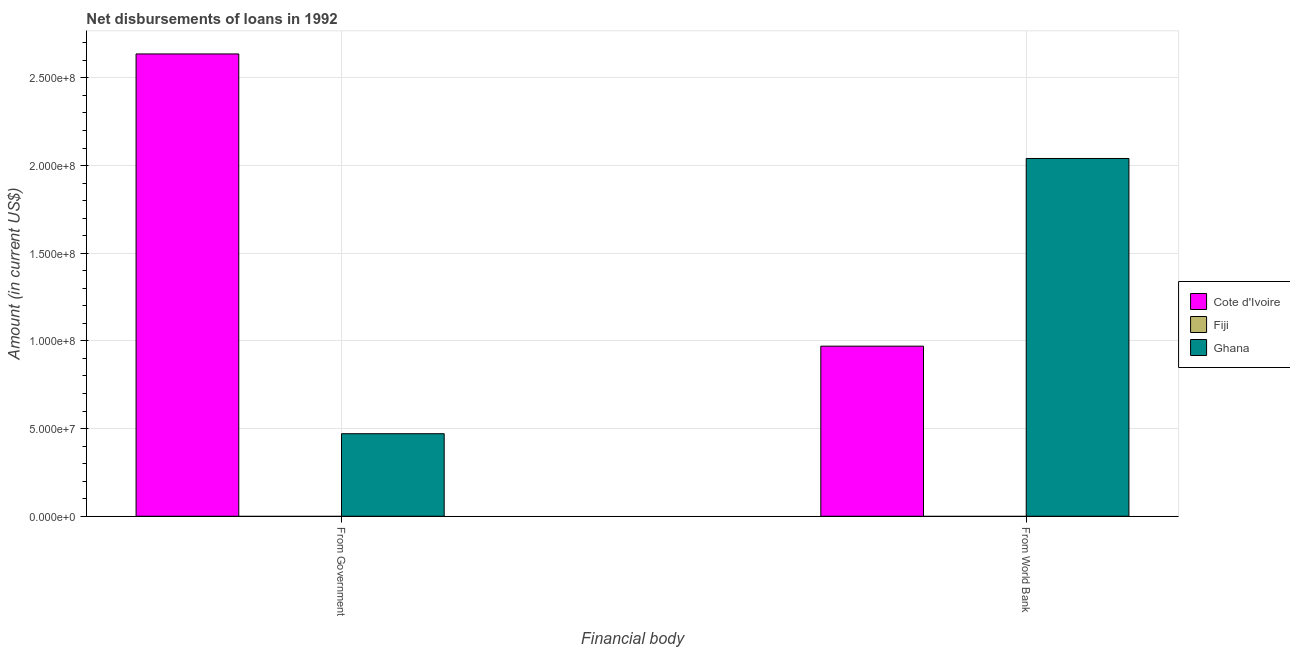How many different coloured bars are there?
Give a very brief answer. 2. Are the number of bars per tick equal to the number of legend labels?
Offer a terse response. No. How many bars are there on the 2nd tick from the left?
Give a very brief answer. 2. How many bars are there on the 2nd tick from the right?
Make the answer very short. 2. What is the label of the 2nd group of bars from the left?
Offer a very short reply. From World Bank. What is the net disbursements of loan from government in Fiji?
Keep it short and to the point. 0. Across all countries, what is the maximum net disbursements of loan from government?
Provide a succinct answer. 2.64e+08. Across all countries, what is the minimum net disbursements of loan from government?
Give a very brief answer. 0. In which country was the net disbursements of loan from world bank maximum?
Give a very brief answer. Ghana. What is the total net disbursements of loan from world bank in the graph?
Your answer should be very brief. 3.01e+08. What is the difference between the net disbursements of loan from government in Ghana and that in Cote d'Ivoire?
Your response must be concise. -2.17e+08. What is the difference between the net disbursements of loan from world bank in Fiji and the net disbursements of loan from government in Cote d'Ivoire?
Provide a succinct answer. -2.64e+08. What is the average net disbursements of loan from government per country?
Your answer should be compact. 1.04e+08. What is the difference between the net disbursements of loan from government and net disbursements of loan from world bank in Cote d'Ivoire?
Keep it short and to the point. 1.67e+08. What is the ratio of the net disbursements of loan from world bank in Cote d'Ivoire to that in Ghana?
Provide a short and direct response. 0.48. Is the net disbursements of loan from world bank in Cote d'Ivoire less than that in Ghana?
Your response must be concise. Yes. How many countries are there in the graph?
Your answer should be compact. 3. What is the difference between two consecutive major ticks on the Y-axis?
Your answer should be compact. 5.00e+07. How many legend labels are there?
Your response must be concise. 3. How are the legend labels stacked?
Make the answer very short. Vertical. What is the title of the graph?
Offer a very short reply. Net disbursements of loans in 1992. Does "Fiji" appear as one of the legend labels in the graph?
Offer a terse response. Yes. What is the label or title of the X-axis?
Provide a succinct answer. Financial body. What is the label or title of the Y-axis?
Your answer should be very brief. Amount (in current US$). What is the Amount (in current US$) in Cote d'Ivoire in From Government?
Provide a succinct answer. 2.64e+08. What is the Amount (in current US$) of Fiji in From Government?
Offer a very short reply. 0. What is the Amount (in current US$) of Ghana in From Government?
Give a very brief answer. 4.71e+07. What is the Amount (in current US$) in Cote d'Ivoire in From World Bank?
Make the answer very short. 9.70e+07. What is the Amount (in current US$) in Fiji in From World Bank?
Keep it short and to the point. 0. What is the Amount (in current US$) in Ghana in From World Bank?
Ensure brevity in your answer.  2.04e+08. Across all Financial body, what is the maximum Amount (in current US$) in Cote d'Ivoire?
Your answer should be compact. 2.64e+08. Across all Financial body, what is the maximum Amount (in current US$) in Ghana?
Keep it short and to the point. 2.04e+08. Across all Financial body, what is the minimum Amount (in current US$) of Cote d'Ivoire?
Ensure brevity in your answer.  9.70e+07. Across all Financial body, what is the minimum Amount (in current US$) of Ghana?
Ensure brevity in your answer.  4.71e+07. What is the total Amount (in current US$) in Cote d'Ivoire in the graph?
Your answer should be compact. 3.61e+08. What is the total Amount (in current US$) in Fiji in the graph?
Offer a very short reply. 0. What is the total Amount (in current US$) of Ghana in the graph?
Provide a short and direct response. 2.51e+08. What is the difference between the Amount (in current US$) of Cote d'Ivoire in From Government and that in From World Bank?
Make the answer very short. 1.67e+08. What is the difference between the Amount (in current US$) of Ghana in From Government and that in From World Bank?
Your answer should be very brief. -1.57e+08. What is the difference between the Amount (in current US$) in Cote d'Ivoire in From Government and the Amount (in current US$) in Ghana in From World Bank?
Keep it short and to the point. 5.96e+07. What is the average Amount (in current US$) of Cote d'Ivoire per Financial body?
Your answer should be very brief. 1.80e+08. What is the average Amount (in current US$) in Fiji per Financial body?
Ensure brevity in your answer.  0. What is the average Amount (in current US$) of Ghana per Financial body?
Your answer should be compact. 1.26e+08. What is the difference between the Amount (in current US$) in Cote d'Ivoire and Amount (in current US$) in Ghana in From Government?
Ensure brevity in your answer.  2.17e+08. What is the difference between the Amount (in current US$) of Cote d'Ivoire and Amount (in current US$) of Ghana in From World Bank?
Offer a terse response. -1.07e+08. What is the ratio of the Amount (in current US$) in Cote d'Ivoire in From Government to that in From World Bank?
Provide a short and direct response. 2.72. What is the ratio of the Amount (in current US$) of Ghana in From Government to that in From World Bank?
Provide a short and direct response. 0.23. What is the difference between the highest and the second highest Amount (in current US$) in Cote d'Ivoire?
Provide a short and direct response. 1.67e+08. What is the difference between the highest and the second highest Amount (in current US$) of Ghana?
Make the answer very short. 1.57e+08. What is the difference between the highest and the lowest Amount (in current US$) in Cote d'Ivoire?
Provide a short and direct response. 1.67e+08. What is the difference between the highest and the lowest Amount (in current US$) in Ghana?
Your answer should be compact. 1.57e+08. 